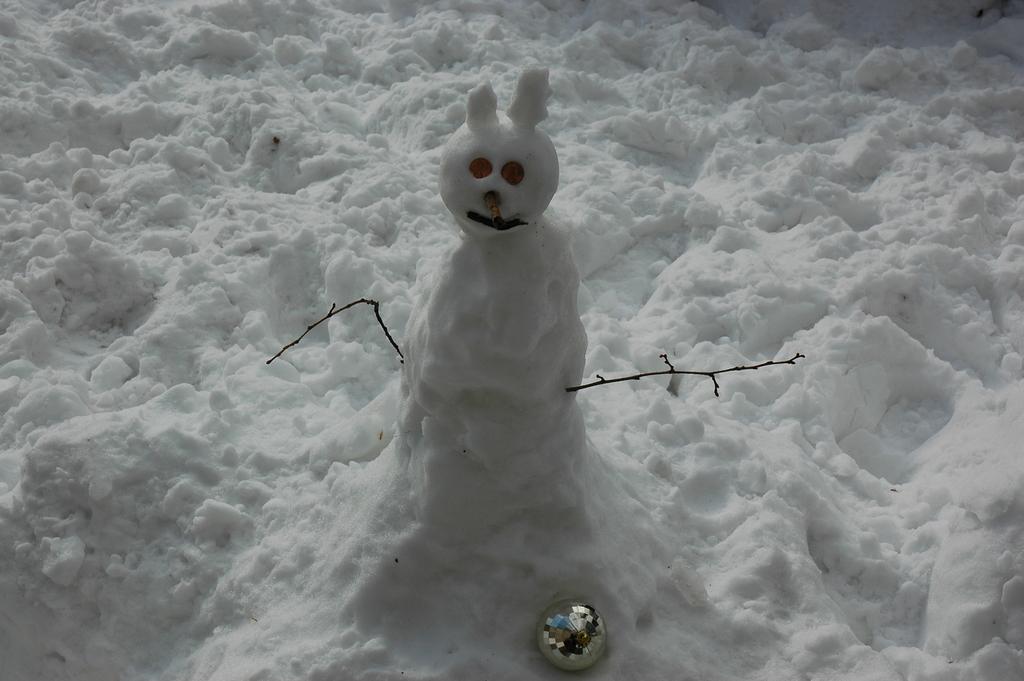Can you describe this image briefly? This picture contains a snowman which is made up of ice. At the bottom of the picture, we see the ball and the ice. 